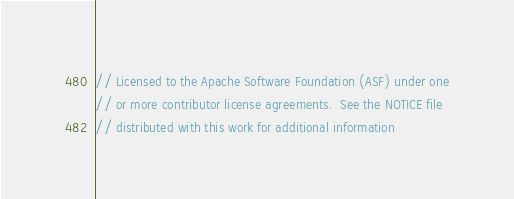Convert code to text. <code><loc_0><loc_0><loc_500><loc_500><_C++_>// Licensed to the Apache Software Foundation (ASF) under one
// or more contributor license agreements.  See the NOTICE file
// distributed with this work for additional information</code> 